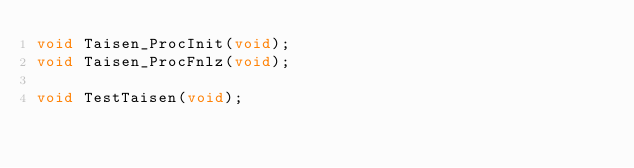<code> <loc_0><loc_0><loc_500><loc_500><_C_>void Taisen_ProcInit(void);
void Taisen_ProcFnlz(void);

void TestTaisen(void);
</code> 